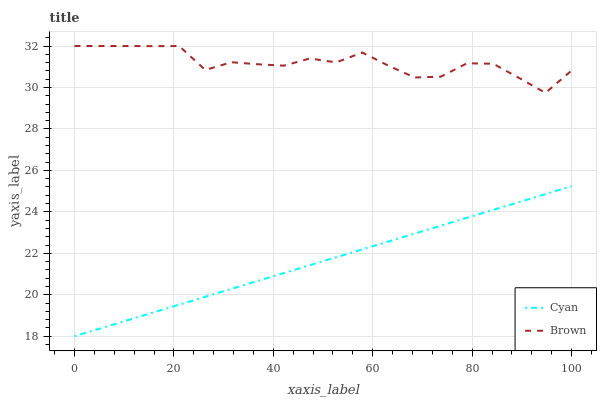Does Cyan have the minimum area under the curve?
Answer yes or no. Yes. Does Brown have the maximum area under the curve?
Answer yes or no. Yes. Does Brown have the minimum area under the curve?
Answer yes or no. No. Is Cyan the smoothest?
Answer yes or no. Yes. Is Brown the roughest?
Answer yes or no. Yes. Is Brown the smoothest?
Answer yes or no. No. Does Cyan have the lowest value?
Answer yes or no. Yes. Does Brown have the lowest value?
Answer yes or no. No. Does Brown have the highest value?
Answer yes or no. Yes. Is Cyan less than Brown?
Answer yes or no. Yes. Is Brown greater than Cyan?
Answer yes or no. Yes. Does Cyan intersect Brown?
Answer yes or no. No. 